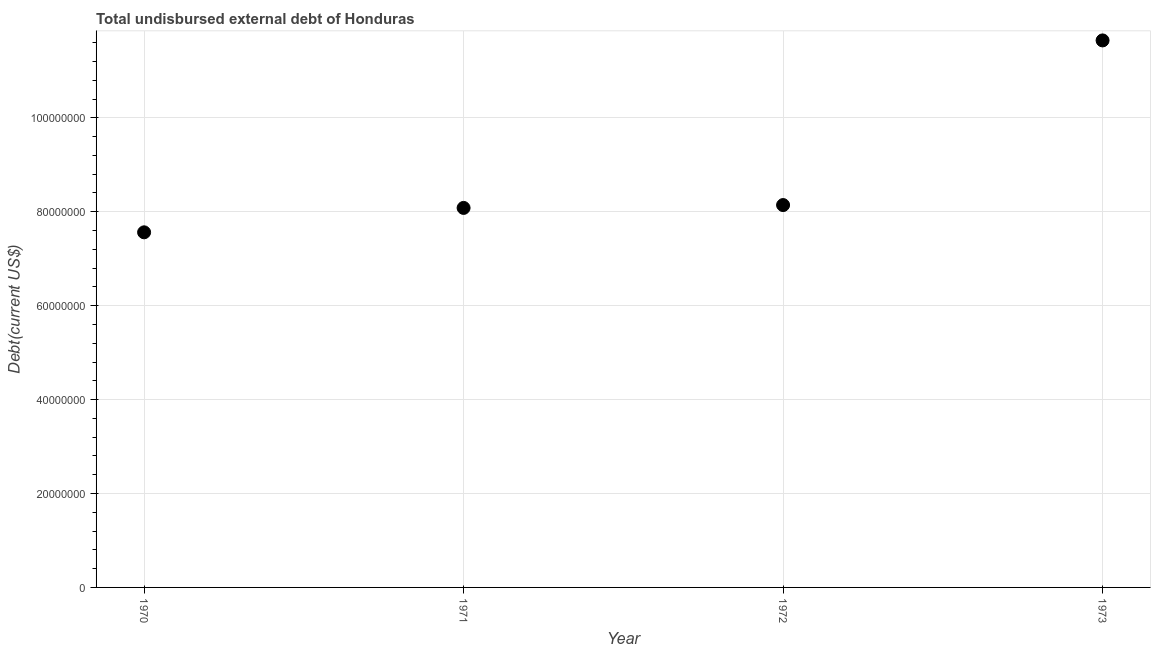What is the total debt in 1970?
Ensure brevity in your answer.  7.56e+07. Across all years, what is the maximum total debt?
Your response must be concise. 1.16e+08. Across all years, what is the minimum total debt?
Provide a short and direct response. 7.56e+07. In which year was the total debt maximum?
Offer a terse response. 1973. In which year was the total debt minimum?
Offer a very short reply. 1970. What is the sum of the total debt?
Make the answer very short. 3.54e+08. What is the difference between the total debt in 1970 and 1971?
Keep it short and to the point. -5.20e+06. What is the average total debt per year?
Your response must be concise. 8.86e+07. What is the median total debt?
Give a very brief answer. 8.11e+07. What is the ratio of the total debt in 1970 to that in 1971?
Offer a terse response. 0.94. Is the difference between the total debt in 1970 and 1971 greater than the difference between any two years?
Keep it short and to the point. No. What is the difference between the highest and the second highest total debt?
Give a very brief answer. 3.51e+07. What is the difference between the highest and the lowest total debt?
Your answer should be compact. 4.09e+07. In how many years, is the total debt greater than the average total debt taken over all years?
Offer a very short reply. 1. Does the total debt monotonically increase over the years?
Keep it short and to the point. Yes. Does the graph contain any zero values?
Provide a short and direct response. No. What is the title of the graph?
Offer a very short reply. Total undisbursed external debt of Honduras. What is the label or title of the Y-axis?
Offer a terse response. Debt(current US$). What is the Debt(current US$) in 1970?
Your answer should be compact. 7.56e+07. What is the Debt(current US$) in 1971?
Provide a short and direct response. 8.08e+07. What is the Debt(current US$) in 1972?
Give a very brief answer. 8.14e+07. What is the Debt(current US$) in 1973?
Make the answer very short. 1.16e+08. What is the difference between the Debt(current US$) in 1970 and 1971?
Your answer should be very brief. -5.20e+06. What is the difference between the Debt(current US$) in 1970 and 1972?
Offer a very short reply. -5.80e+06. What is the difference between the Debt(current US$) in 1970 and 1973?
Your answer should be compact. -4.09e+07. What is the difference between the Debt(current US$) in 1971 and 1972?
Give a very brief answer. -6.09e+05. What is the difference between the Debt(current US$) in 1971 and 1973?
Ensure brevity in your answer.  -3.57e+07. What is the difference between the Debt(current US$) in 1972 and 1973?
Your response must be concise. -3.51e+07. What is the ratio of the Debt(current US$) in 1970 to that in 1971?
Make the answer very short. 0.94. What is the ratio of the Debt(current US$) in 1970 to that in 1972?
Your answer should be compact. 0.93. What is the ratio of the Debt(current US$) in 1970 to that in 1973?
Provide a short and direct response. 0.65. What is the ratio of the Debt(current US$) in 1971 to that in 1972?
Your response must be concise. 0.99. What is the ratio of the Debt(current US$) in 1971 to that in 1973?
Make the answer very short. 0.69. What is the ratio of the Debt(current US$) in 1972 to that in 1973?
Give a very brief answer. 0.7. 